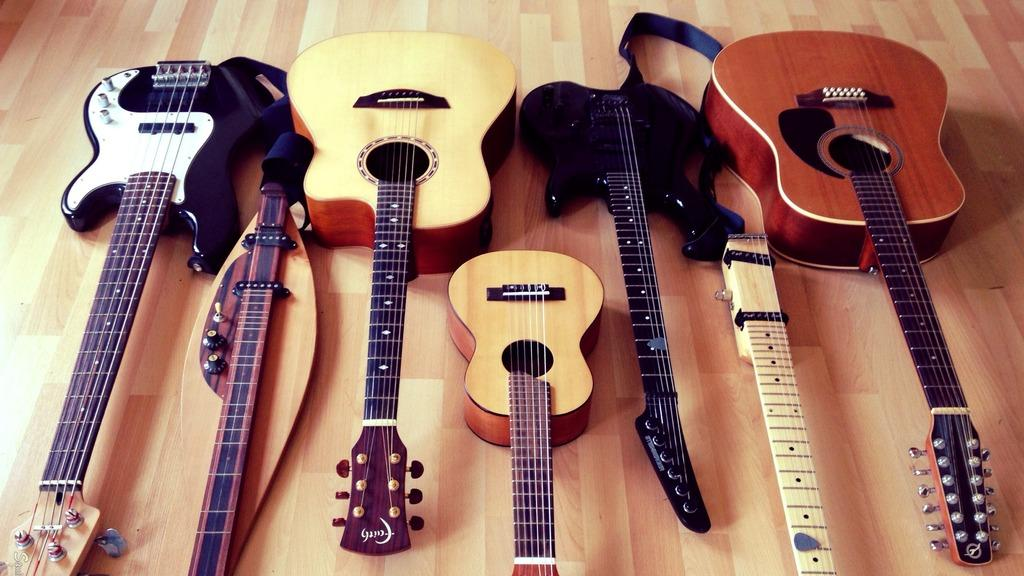What is the main subject of the image? The main subject of the image is a group of musical instruments. Where are the musical instruments located in the image? The musical instruments are on the floor. What type of plants can be seen growing among the musical instruments in the image? There are no plants visible among the musical instruments in the image. How many stars can be seen in the image? There are no stars visible in the image. Are there any sisters playing the musical instruments in the image? There is no information about any sisters playing the musical instruments in the image. 